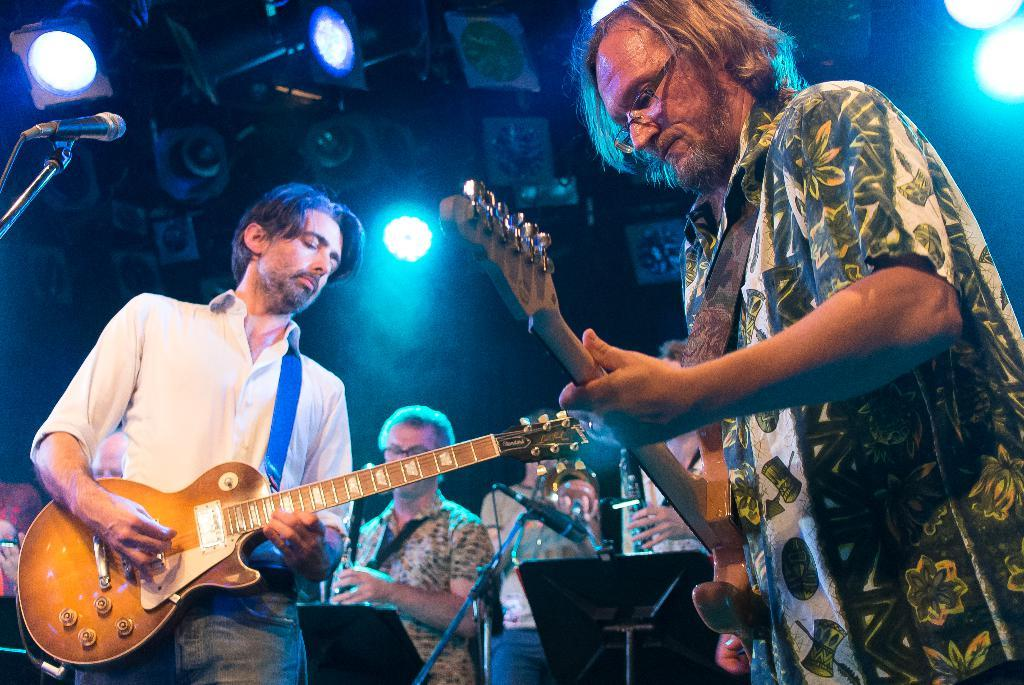What can be seen in the image that provides illumination? There are lights in the image. Who or what is present in the image? There are people in the image. What are two of the people holding in the image? Two people are holding guitars in the image. What type of brush can be seen in the image? There is no brush present in the image. What smell is associated with the people in the image? There is no information about smells in the image, so it cannot be determined. 